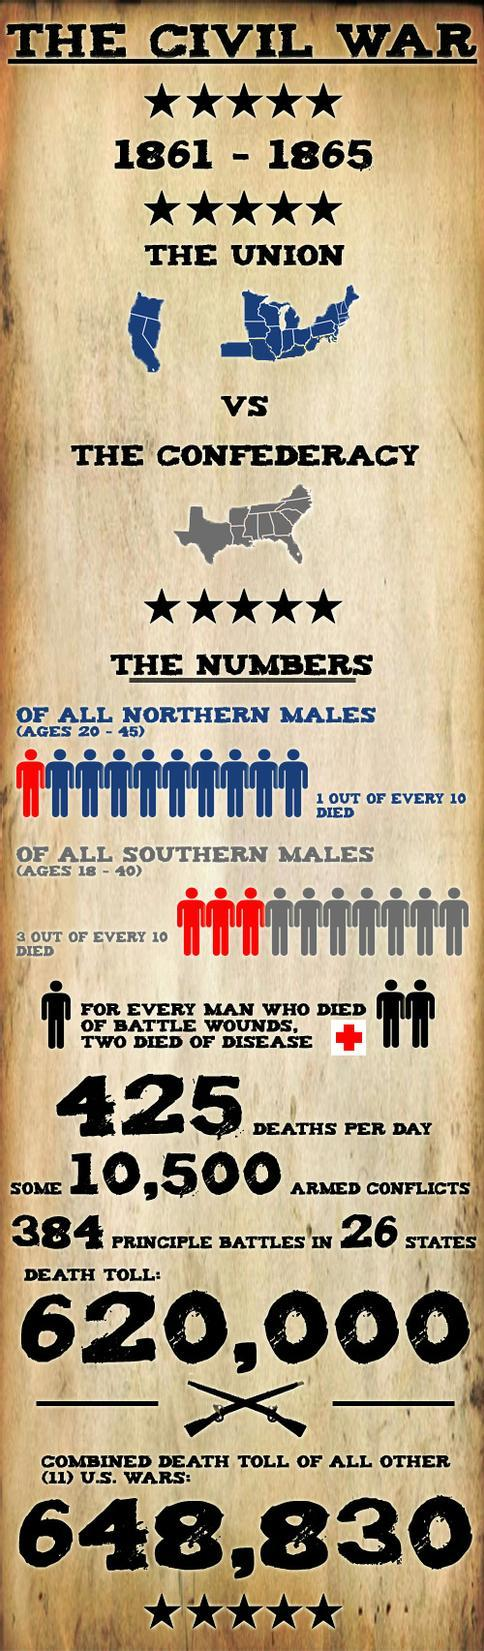List a handful of essential elements in this visual. The American Civil War began in 1861. 